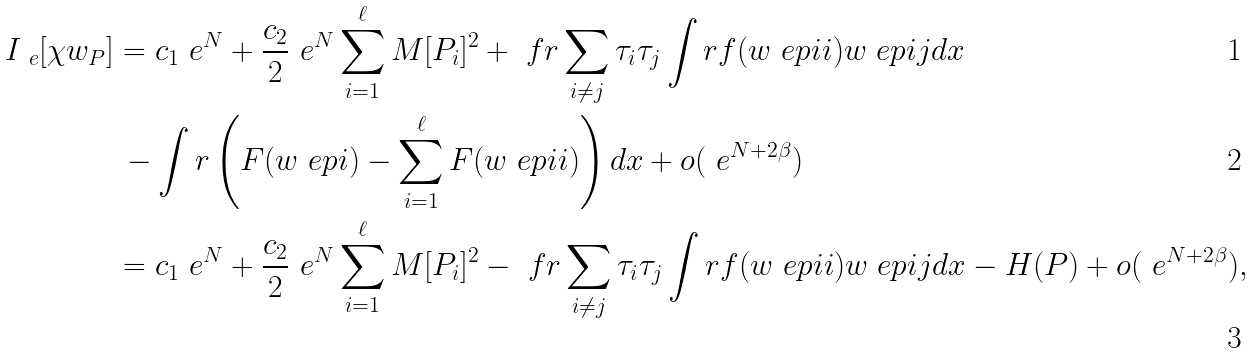<formula> <loc_0><loc_0><loc_500><loc_500>I _ { \ e } [ \chi w _ { P } ] & = c _ { 1 } \ e ^ { N } + \frac { c _ { 2 } } { 2 } \ e ^ { N } \sum _ { i = 1 } ^ { \ell } M [ P _ { i } ] ^ { 2 } + \ f r \sum _ { i \neq j } \tau _ { i } \tau _ { j } \int r f ( w _ { \ } e p i i ) w _ { \ } e p i j d x \\ & \, - \int r \left ( F ( w _ { \ } e p i ) - \sum _ { i = 1 } ^ { \ell } F ( w _ { \ } e p i i ) \right ) d x + o ( \ e ^ { N + 2 \beta } ) \\ & = c _ { 1 } \ e ^ { N } + \frac { c _ { 2 } } { 2 } \ e ^ { N } \sum _ { i = 1 } ^ { \ell } M [ P _ { i } ] ^ { 2 } - \ f r \sum _ { i \neq j } \tau _ { i } \tau _ { j } \int r f ( w _ { \ } e p i i ) w _ { \ } e p i j d x - H ( { P } ) + o ( \ e ^ { N + 2 \beta } ) ,</formula> 